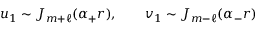Convert formula to latex. <formula><loc_0><loc_0><loc_500><loc_500>u _ { 1 } \sim J _ { m + \ell } ( \alpha _ { + } r ) , \quad v _ { 1 } \sim J _ { m - \ell } ( \alpha _ { - } r )</formula> 